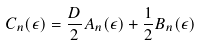Convert formula to latex. <formula><loc_0><loc_0><loc_500><loc_500>C _ { n } ( \epsilon ) = \frac { D } { 2 } A _ { n } ( \epsilon ) + \frac { 1 } { 2 } B _ { n } ( \epsilon )</formula> 